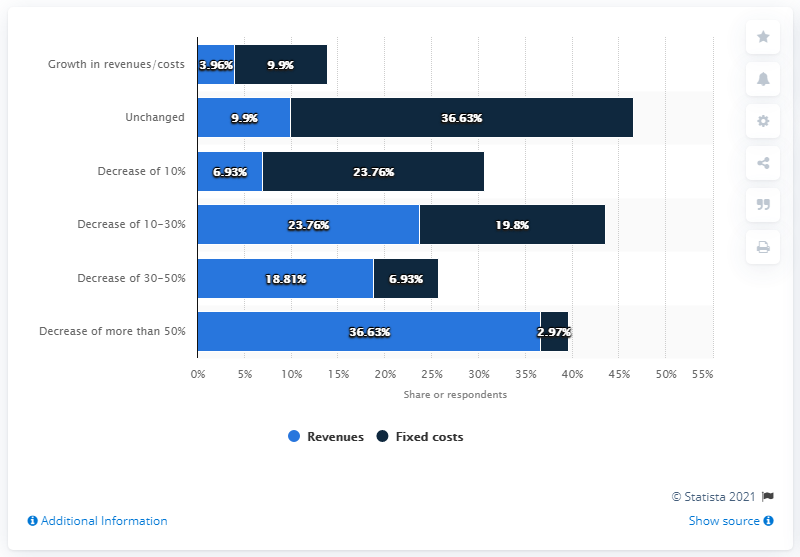List a handful of essential elements in this visual. According to the forecast made by managers, there is a strong possibility that the GDP of Poland will drop by 10 percent due to the outbreak of coronavirus. Specifically, 23.76 percent of managers have forecasted this drop. 